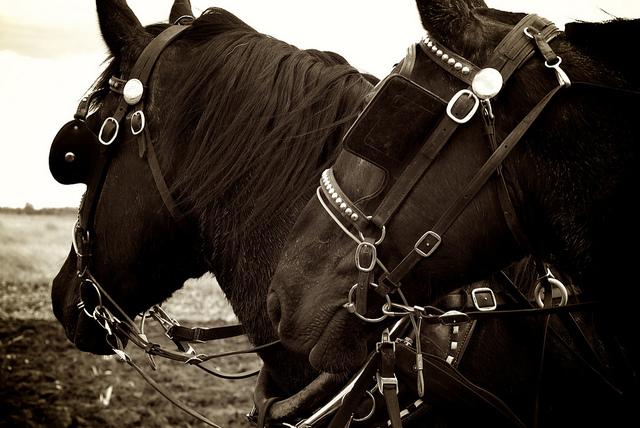What color is the photo tinted?
Be succinct. Sepia. What is on the horse's eyes?
Short answer required. Blinders. What kind of animals can be seen?
Short answer required. Horses. 